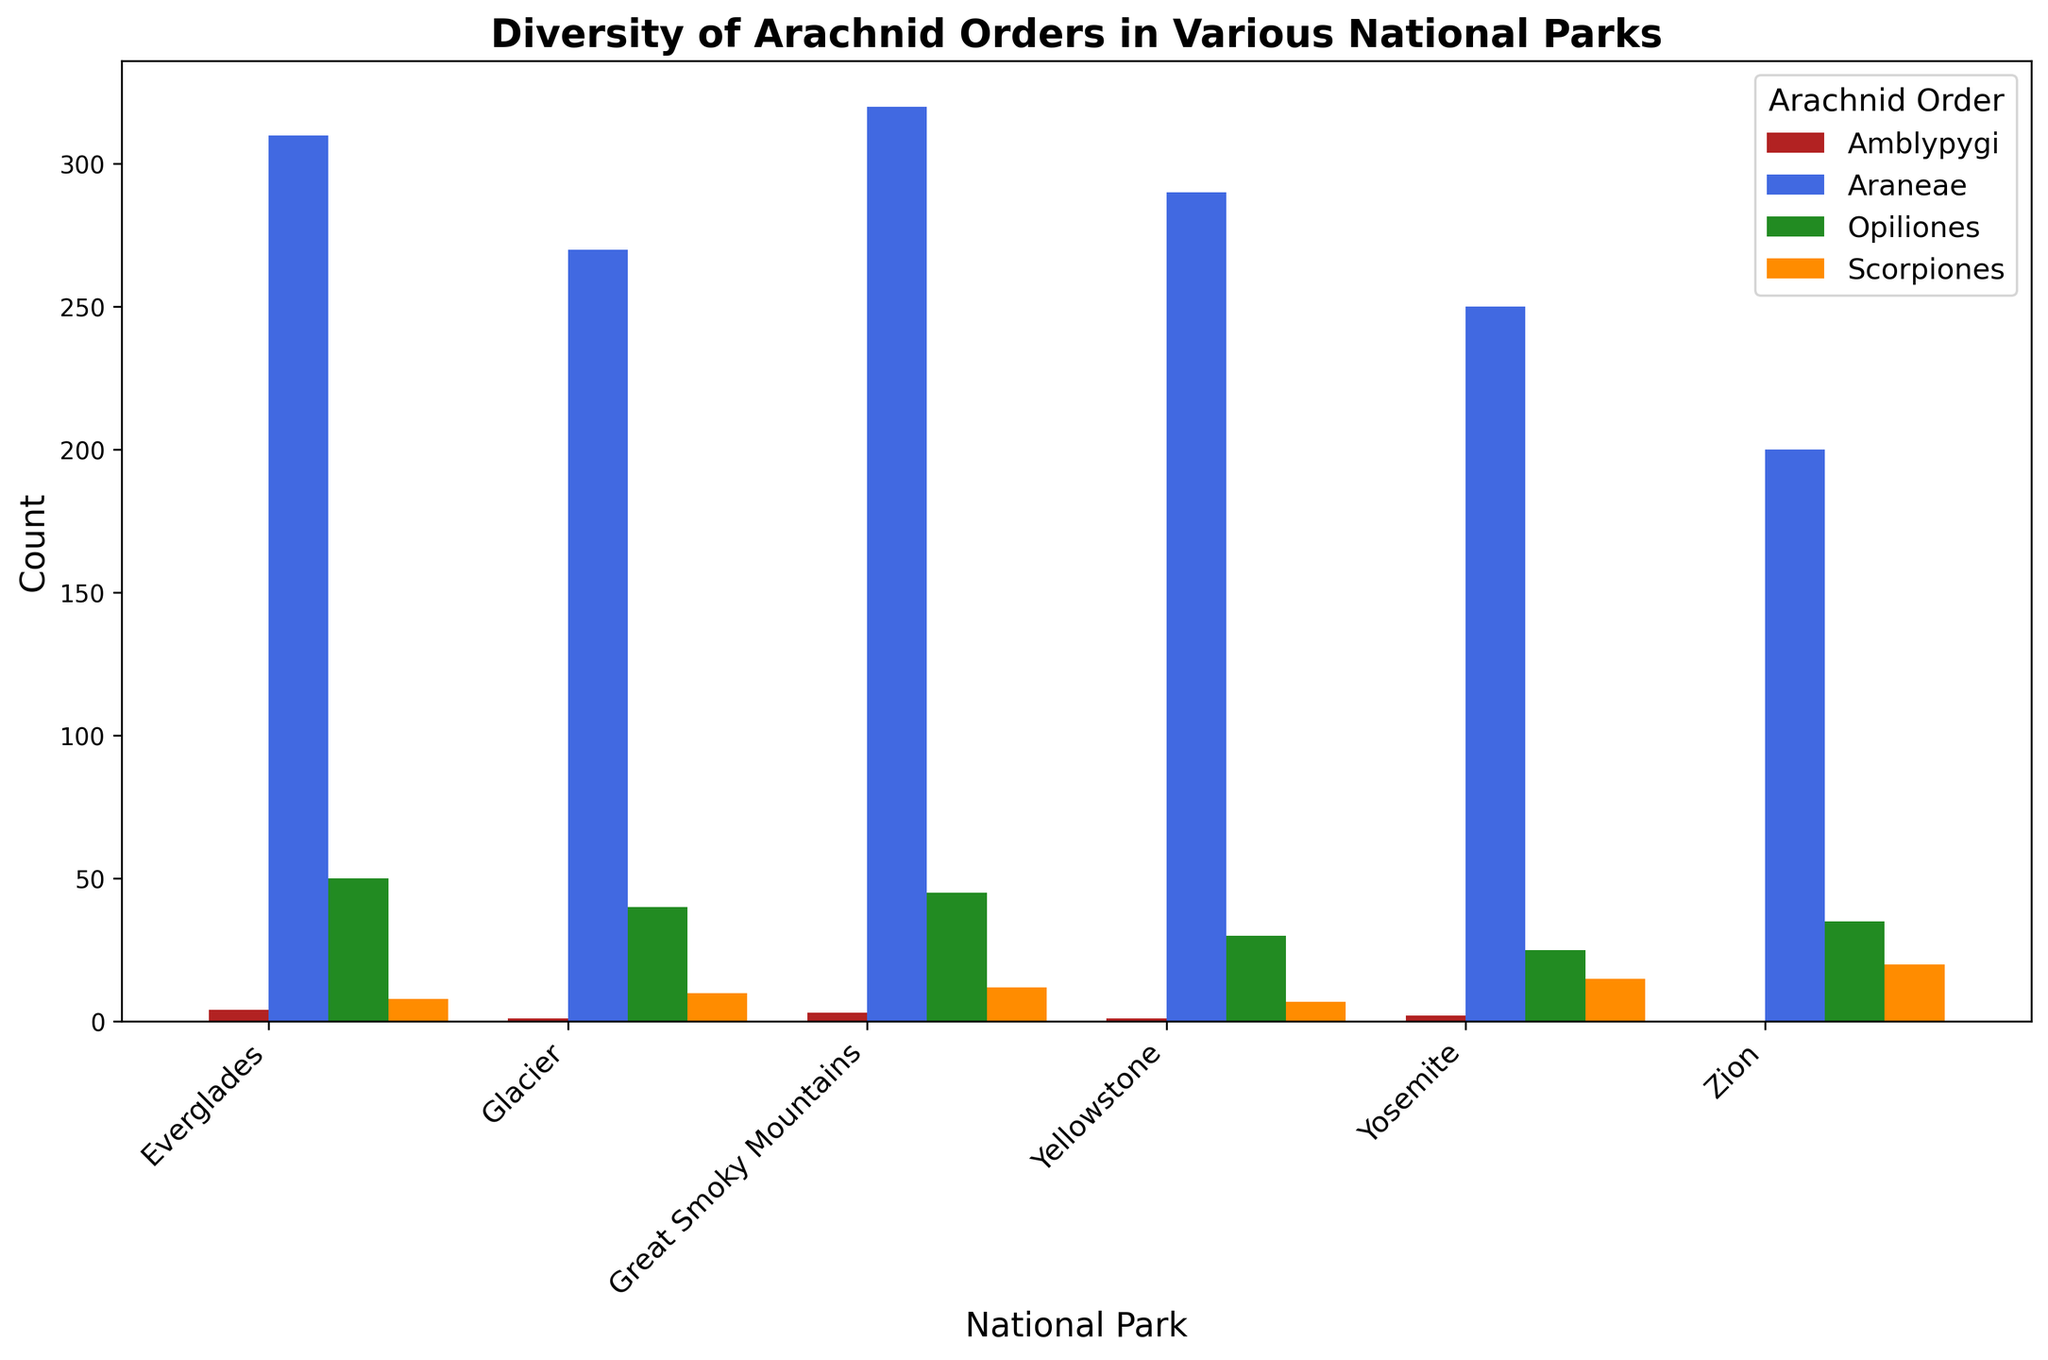Which National Park has the highest count of Araneae? To find the National Park with the highest count of Araneae, look at the height of the bars colored in royal blue. The Great Smoky Mountains has the tallest bar in this category.
Answer: Great Smoky Mountains Which National Park has the lowest count of Amblypygi? To determine the National Park with the lowest count of Amblypygi, look for the shortest bars colored in firebrick. Zion has a count of 0.
Answer: Zion Which Arachnid Order has the overall highest count across all National Parks? To figure this out, focus on each Arachnid Order separately and sum their counts across all National Parks. Araneae clearly has the tallest bars across all National Parks.
Answer: Araneae What is the average count of Scorpiones across all National Parks? To find the average count, sum the counts of Scorpiones for all parks (12 + 7 + 15 + 20 + 10 + 8) = 72, then divide by the number of parks (6). The average is 72/6 = 12.
Answer: 12 Which National Park has the greatest diversity in terms of the range of counts for different Arachnid Orders? Look at the difference between the highest and lowest counts in each National Park. The Great Smoky Mountains has a range from 320 (Araneae) to 3 (Amblypygi), which is the largest range of 317.
Answer: Great Smoky Mountains How many more Opiliones are there in Everglades compared to Zion? Subtract the count of Opiliones in Zion (35) from the count in Everglades (50), giving 50 - 35 = 15.
Answer: 15 Which Arachnid Order has the lowest count in Yellowstone? Examine the bars for each Arachnid Order within Yellowstone. Amblypygi has the lowest count at 1.
Answer: Amblypygi Is the count of Araneae in Great Smoky Mountains greater than the combined count of Scorpiones and Opiliones in Yosemite? Check the counts: Araneae in Great Smoky Mountains is 320, Scorpiones in Yosemite is 15, and Opiliones in Yosemite is 25. Combined count of Scorpiones and Opiliones in Yosemite is 15 + 25 = 40. 320 is greater than 40.
Answer: Yes What is the total count of Opiliones and Scorpiones across all National Parks? Sum the counts of Opiliones (45 + 30 + 25 + 35 + 40 + 50) = 225 and Scorpiones (12 + 7 + 15 + 20 + 10 + 8) = 72, then add these sums together: 225 + 72 = 297.
Answer: 297 